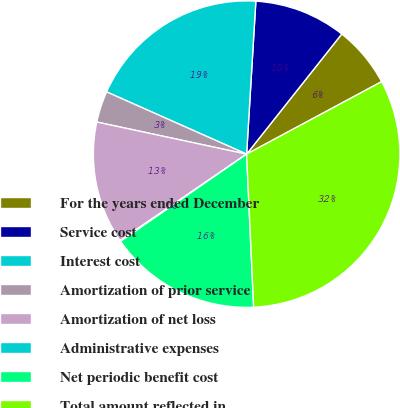<chart> <loc_0><loc_0><loc_500><loc_500><pie_chart><fcel>For the years ended December<fcel>Service cost<fcel>Interest cost<fcel>Amortization of prior service<fcel>Amortization of net loss<fcel>Administrative expenses<fcel>Net periodic benefit cost<fcel>Total amount reflected in<nl><fcel>6.5%<fcel>9.7%<fcel>19.3%<fcel>3.3%<fcel>12.9%<fcel>0.09%<fcel>16.1%<fcel>32.11%<nl></chart> 